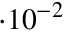Convert formula to latex. <formula><loc_0><loc_0><loc_500><loc_500>\cdot 1 0 ^ { - 2 }</formula> 